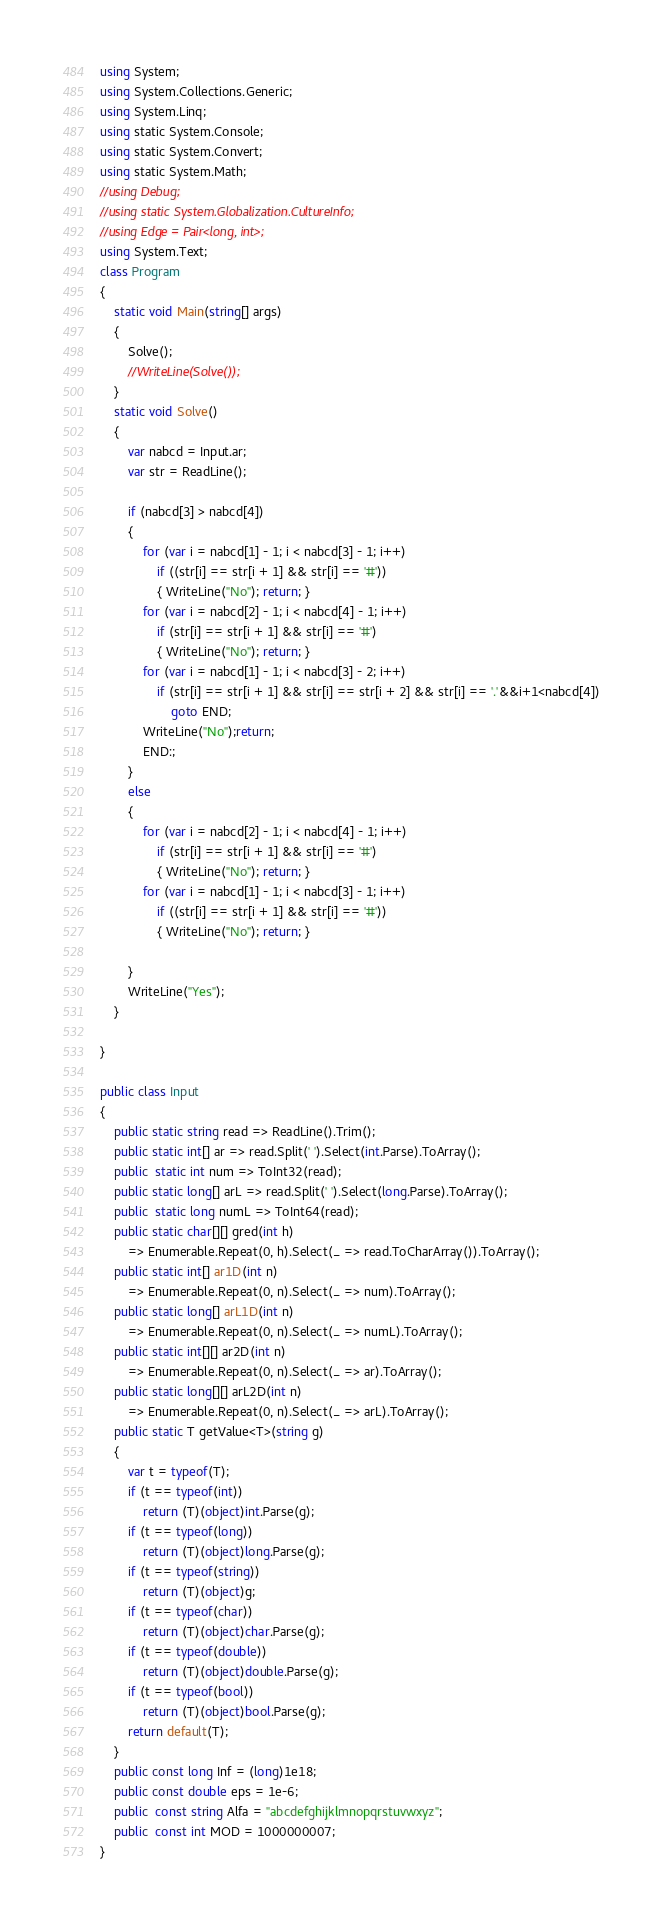<code> <loc_0><loc_0><loc_500><loc_500><_C#_>using System;
using System.Collections.Generic;
using System.Linq;
using static System.Console;
using static System.Convert;
using static System.Math;
//using Debug;
//using static System.Globalization.CultureInfo;
//using Edge = Pair<long, int>;
using System.Text;
class Program
{ 
    static void Main(string[] args)
    {
        Solve();
        //WriteLine(Solve());
    }
    static void Solve()
    {
        var nabcd = Input.ar;
        var str = ReadLine();

        if (nabcd[3] > nabcd[4])
        {
            for (var i = nabcd[1] - 1; i < nabcd[3] - 1; i++)
                if ((str[i] == str[i + 1] && str[i] == '#'))
                { WriteLine("No"); return; }
            for (var i = nabcd[2] - 1; i < nabcd[4] - 1; i++)
                if (str[i] == str[i + 1] && str[i] == '#')
                { WriteLine("No"); return; }
            for (var i = nabcd[1] - 1; i < nabcd[3] - 2; i++)
                if (str[i] == str[i + 1] && str[i] == str[i + 2] && str[i] == '.'&&i+1<nabcd[4])
                    goto END;
            WriteLine("No");return;
            END:;
        }
        else
        {
            for (var i = nabcd[2] - 1; i < nabcd[4] - 1; i++)
                if (str[i] == str[i + 1] && str[i] == '#')
                { WriteLine("No"); return; }
            for (var i = nabcd[1] - 1; i < nabcd[3] - 1; i++)
                if ((str[i] == str[i + 1] && str[i] == '#'))
                { WriteLine("No"); return; }

        }
        WriteLine("Yes");
    }
    
}

public class Input
{
    public static string read => ReadLine().Trim();
    public static int[] ar => read.Split(' ').Select(int.Parse).ToArray();
    public  static int num => ToInt32(read);
    public static long[] arL => read.Split(' ').Select(long.Parse).ToArray();
    public  static long numL => ToInt64(read);
    public static char[][] gred(int h) 
        => Enumerable.Repeat(0, h).Select(_ => read.ToCharArray()).ToArray();
    public static int[] ar1D(int n)
        => Enumerable.Repeat(0, n).Select(_ => num).ToArray();
    public static long[] arL1D(int n)
        => Enumerable.Repeat(0, n).Select(_ => numL).ToArray();
    public static int[][] ar2D(int n)
        => Enumerable.Repeat(0, n).Select(_ => ar).ToArray();
    public static long[][] arL2D(int n)
        => Enumerable.Repeat(0, n).Select(_ => arL).ToArray();
    public static T getValue<T>(string g)
    {
        var t = typeof(T);
        if (t == typeof(int))
            return (T)(object)int.Parse(g);
        if (t == typeof(long))
            return (T)(object)long.Parse(g);
        if (t == typeof(string))
            return (T)(object)g;
        if (t == typeof(char))
            return (T)(object)char.Parse(g);
        if (t == typeof(double))
            return (T)(object)double.Parse(g);
        if (t == typeof(bool))
            return (T)(object)bool.Parse(g);
        return default(T);
    }
    public const long Inf = (long)1e18;
    public const double eps = 1e-6;
    public  const string Alfa = "abcdefghijklmnopqrstuvwxyz";
    public  const int MOD = 1000000007;
}
</code> 